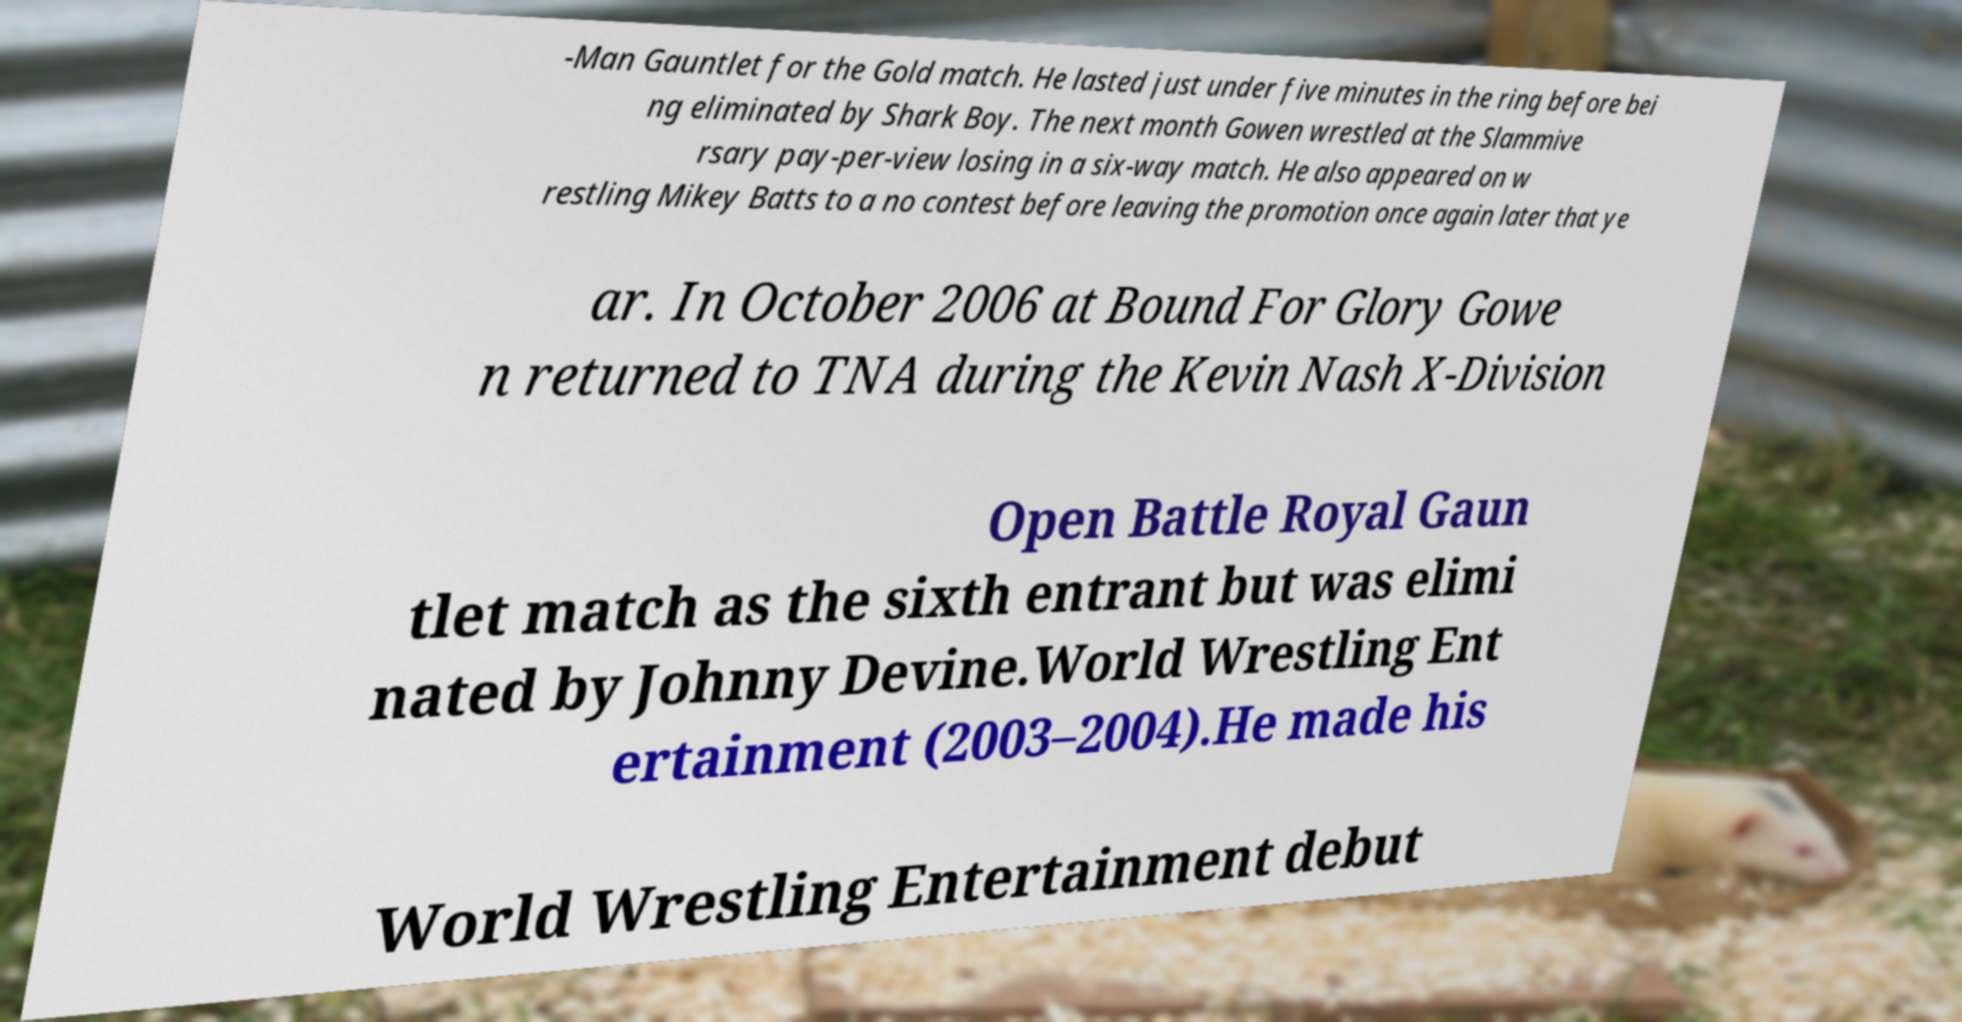For documentation purposes, I need the text within this image transcribed. Could you provide that? -Man Gauntlet for the Gold match. He lasted just under five minutes in the ring before bei ng eliminated by Shark Boy. The next month Gowen wrestled at the Slammive rsary pay-per-view losing in a six-way match. He also appeared on w restling Mikey Batts to a no contest before leaving the promotion once again later that ye ar. In October 2006 at Bound For Glory Gowe n returned to TNA during the Kevin Nash X-Division Open Battle Royal Gaun tlet match as the sixth entrant but was elimi nated by Johnny Devine.World Wrestling Ent ertainment (2003–2004).He made his World Wrestling Entertainment debut 